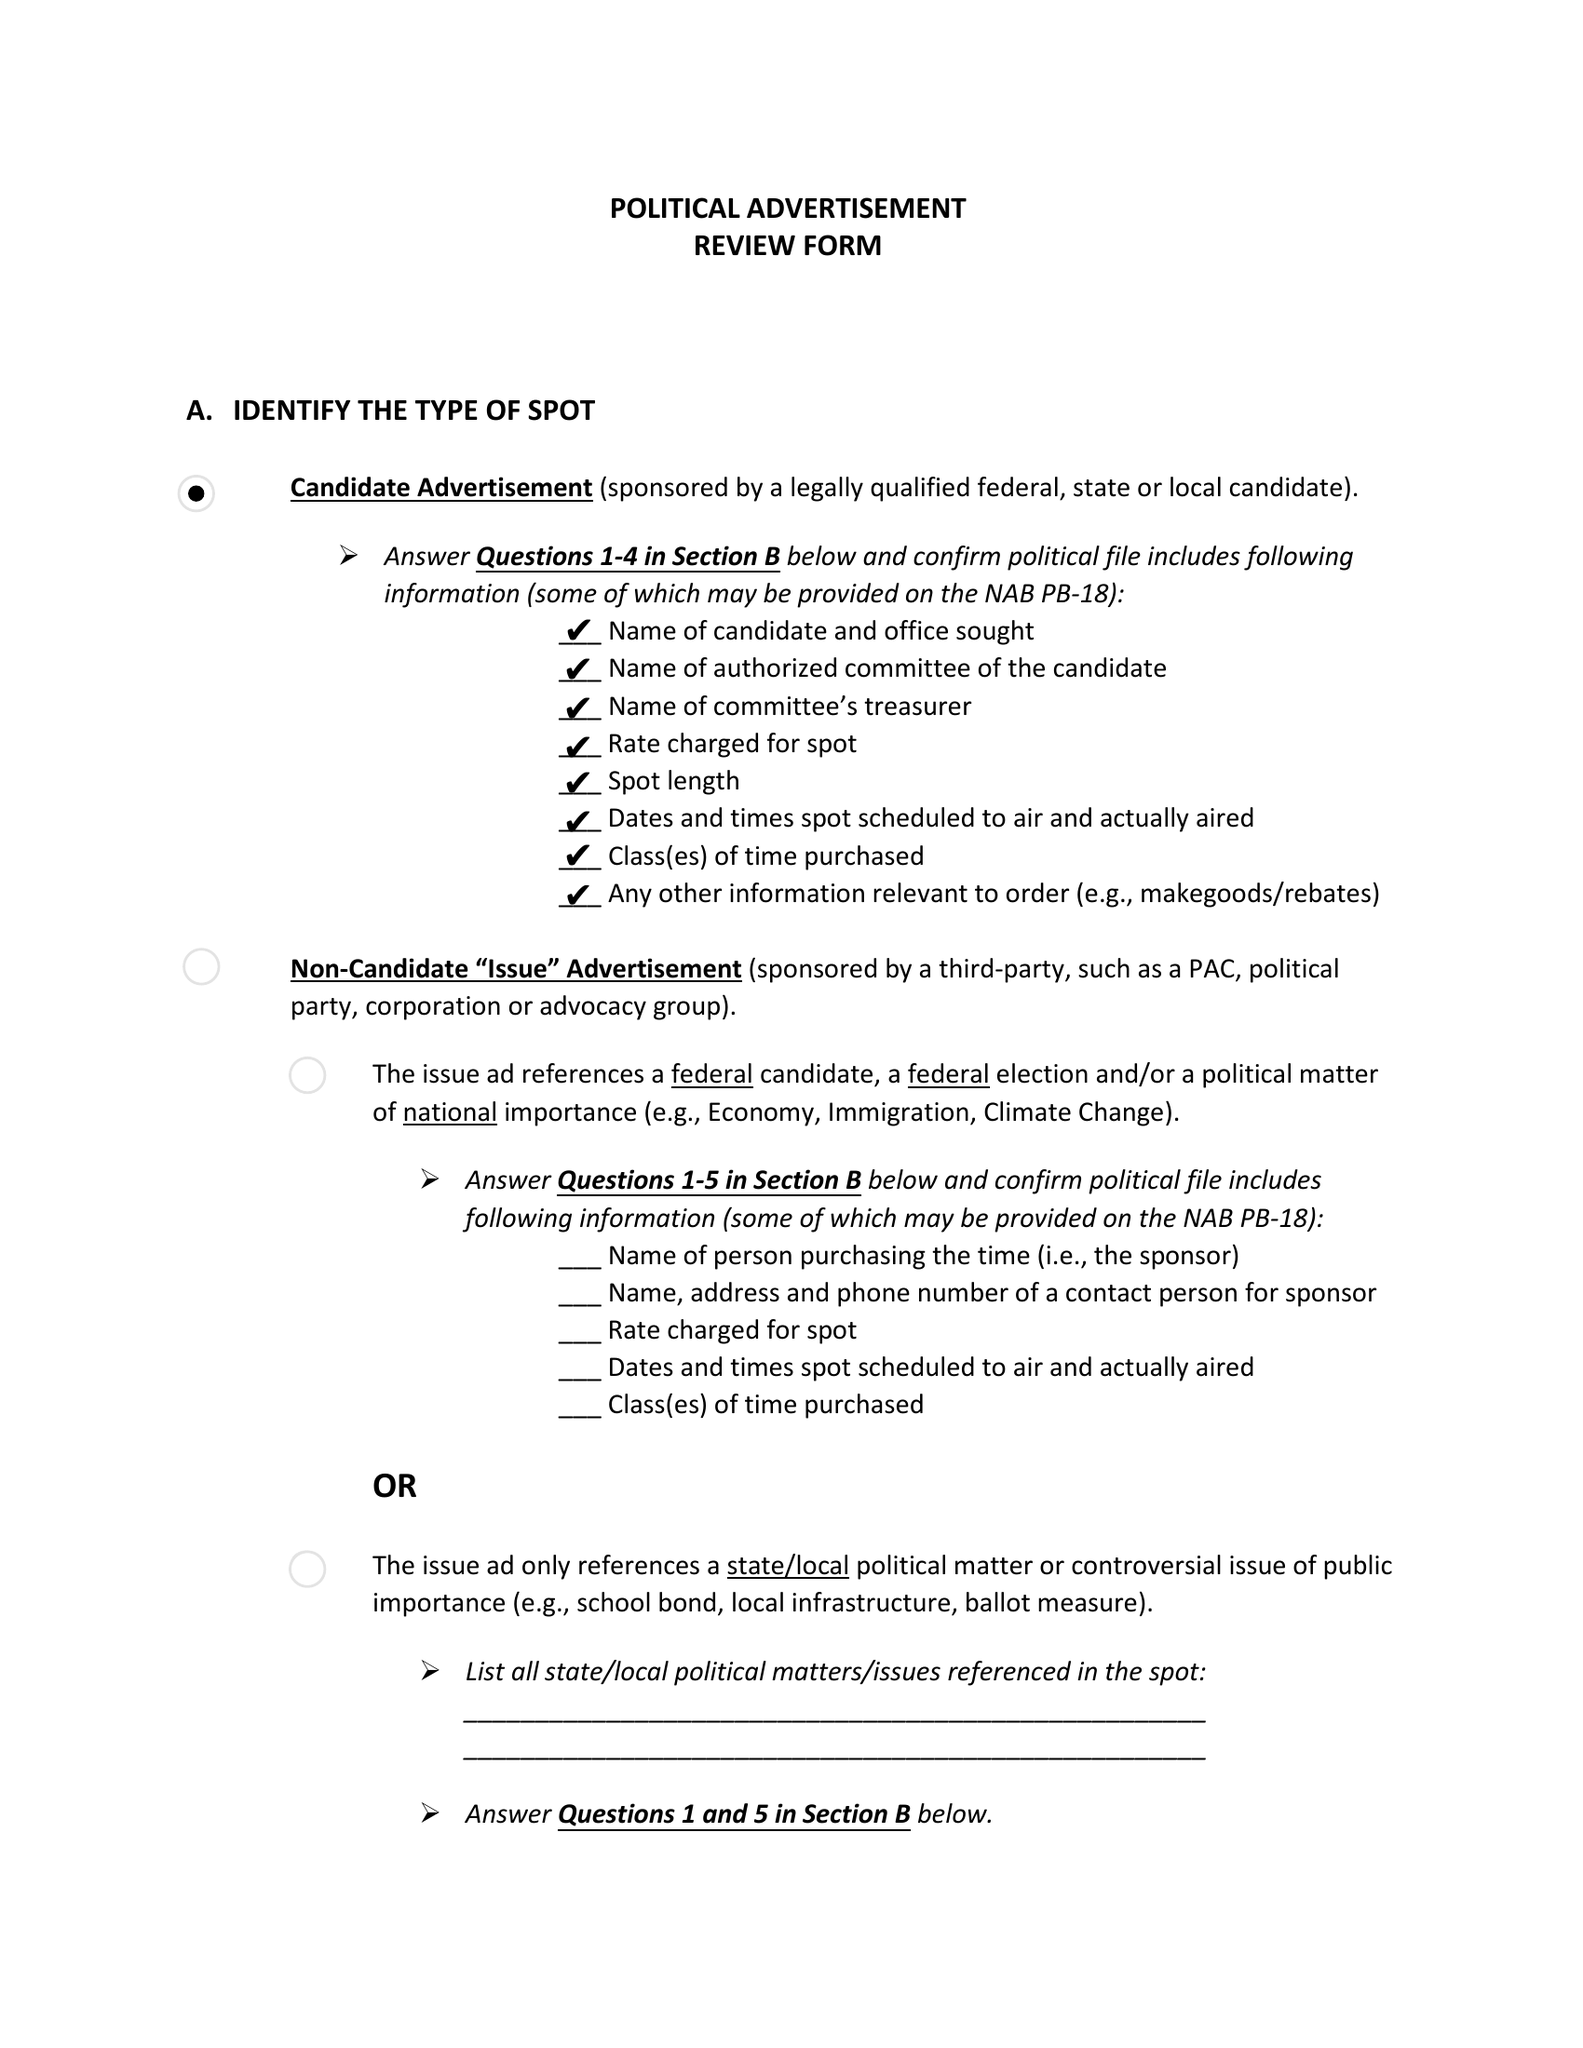What is the value for the contract_num?
Answer the question using a single word or phrase. None 